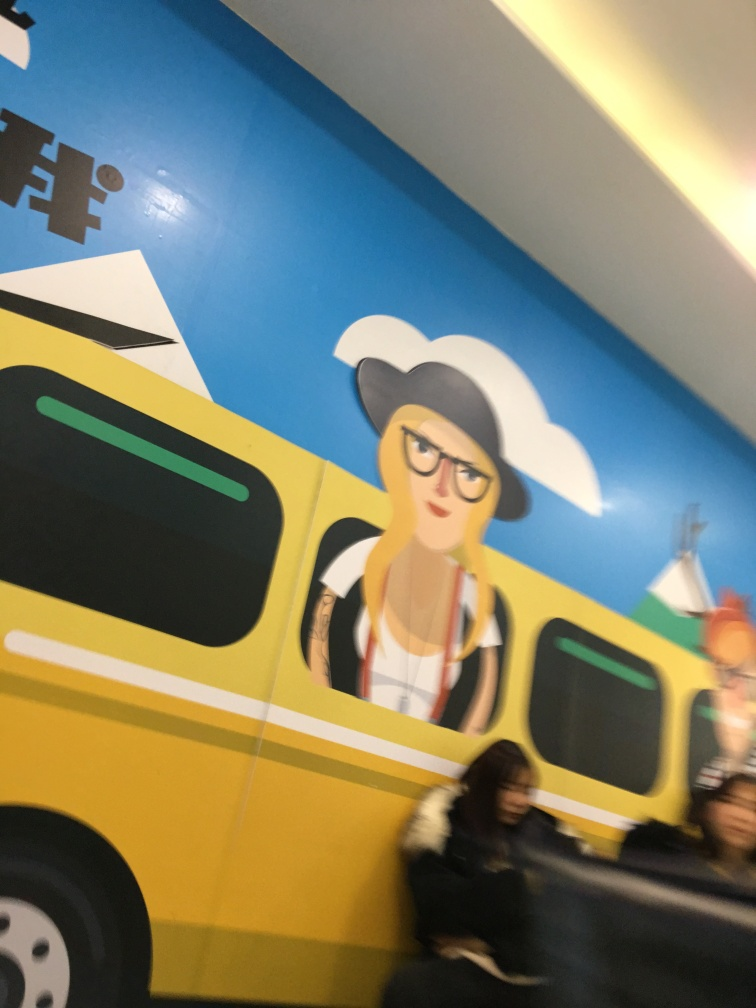How would you describe the overall clarity of this image? The overall clarity of this image is somewhat compromised, likely due to motion blur and camera shake, causing the details to appear smeared and the edges to lack sharpness. This creates a visual effect where the content of the image is recognizable but lacks the crispness you would expect from a clear photograph. 